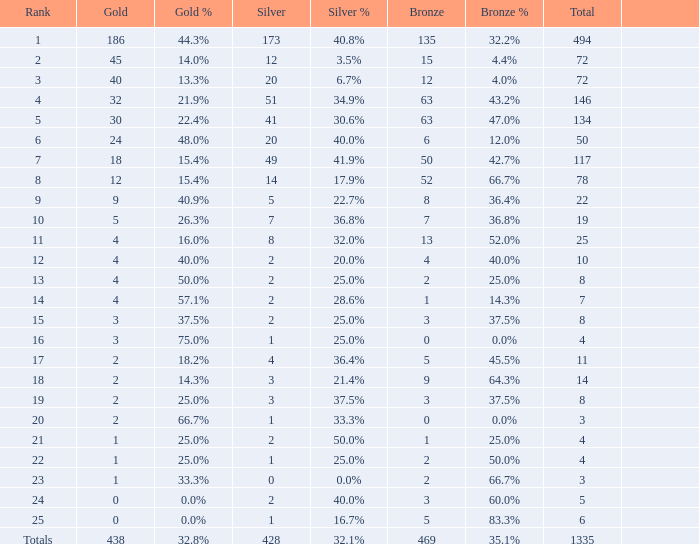Give me the full table as a dictionary. {'header': ['Rank', 'Gold', 'Gold %', 'Silver', 'Silver %', 'Bronze', 'Bronze %', 'Total', ''], 'rows': [['1', '186', '44.3%', '173', '40.8%', '135', '32.2%', '494', ''], ['2', '45', '14.0%', '12', '3.5%', '15', '4.4%', '72', ''], ['3', '40', '13.3%', '20', '6.7%', '12', '4.0%', '72', ''], ['4', '32', '21.9%', '51', '34.9%', '63', '43.2%', '146', ''], ['5', '30', '22.4%', '41', '30.6%', '63', '47.0%', '134', ''], ['6', '24', '48.0%', '20', '40.0%', '6', '12.0%', '50', ''], ['7', '18', '15.4%', '49', '41.9%', '50', '42.7%', '117', ''], ['8', '12', '15.4%', '14', '17.9%', '52', '66.7%', '78', ''], ['9', '9', '40.9%', '5', '22.7%', '8', '36.4%', '22', ''], ['10', '5', '26.3%', '7', '36.8%', '7', '36.8%', '19', ''], ['11', '4', '16.0%', '8', '32.0%', '13', '52.0%', '25', ''], ['12', '4', '40.0%', '2', '20.0%', '4', '40.0%', '10', ''], ['13', '4', '50.0%', '2', '25.0%', '2', '25.0%', '8', ''], ['14', '4', '57.1%', '2', '28.6%', '1', '14.3%', '7', ''], ['15', '3', '37.5%', '2', '25.0%', '3', '37.5%', '8', ''], ['16', '3', '75.0%', '1', '25.0%', '0', '0.0%', '4', ''], ['17', '2', '18.2%', '4', '36.4%', '5', '45.5%', '11', ''], ['18', '2', '14.3%', '3', '21.4%', '9', '64.3%', '14', ''], ['19', '2', '25.0%', '3', '37.5%', '3', '37.5%', '8', ''], ['20', '2', '66.7%', '1', '33.3%', '0', '0.0%', '3', ''], ['21', '1', '25.0%', '2', '50.0%', '1', '25.0%', '4', ''], ['22', '1', '25.0%', '1', '25.0%', '2', '50.0%', '4', ''], ['23', '1', '33.3%', '0', '0.0%', '2', '66.7%', '3', ''], ['24', '0', '0.0%', '2', '40.0%', '3', '60.0%', '5', ''], ['25', '0', '0.0%', '1', '16.7%', '5', '83.3%', '6', ''], ['Totals', '438', '32.8%', '428', '32.1%', '469', '35.1%', '1335', '']]} What is the average number of gold medals when the total was 1335 medals, with more than 469 bronzes and more than 14 silvers? None. 